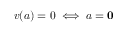Convert formula to latex. <formula><loc_0><loc_0><loc_500><loc_500>v ( a ) = 0 \iff a = 0</formula> 